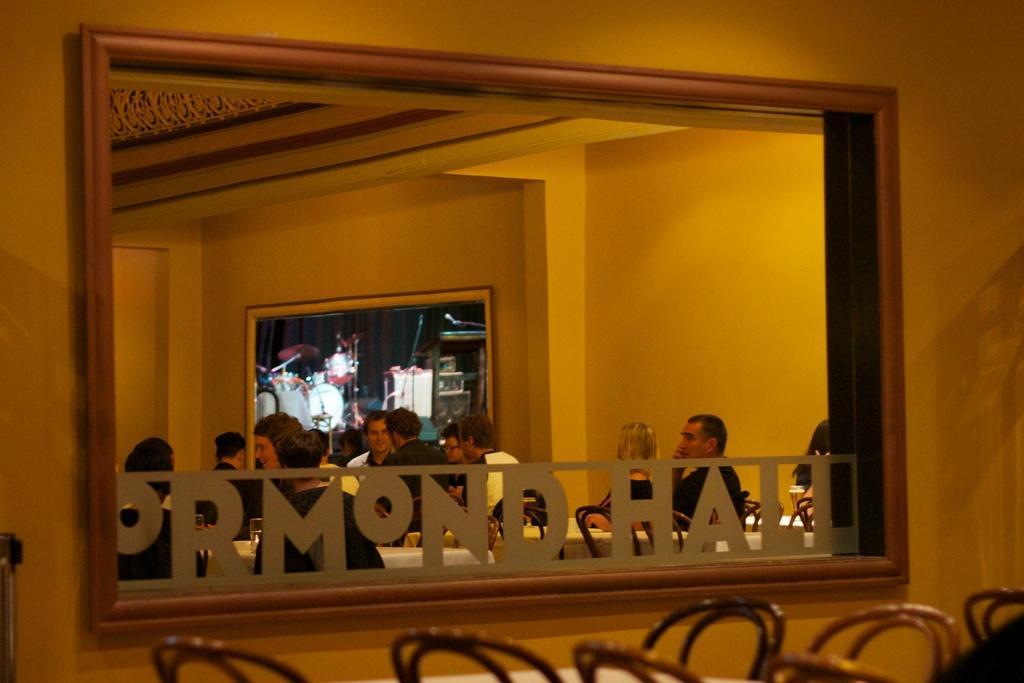Describe this image in one or two sentences. In this image I can see a wall and window. In the background I can see few people are sitting around the tables. At the a screen is attached to a wall. At the bottom of this image I can see some empty chairs. 